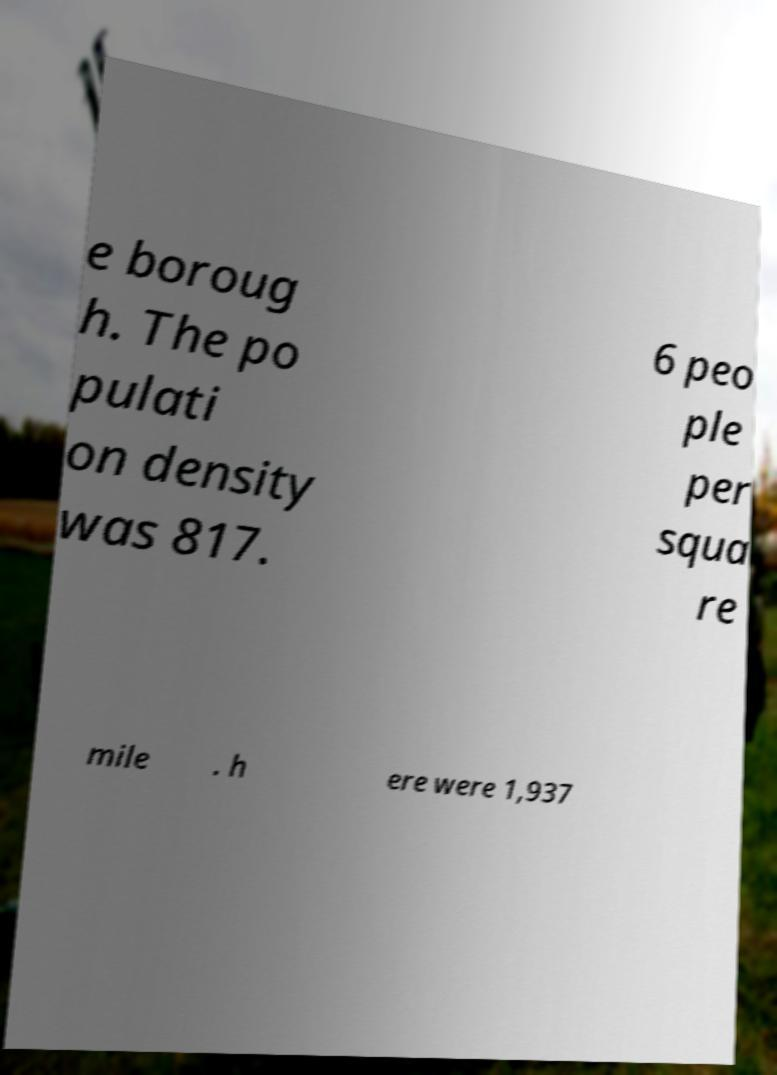There's text embedded in this image that I need extracted. Can you transcribe it verbatim? e boroug h. The po pulati on density was 817. 6 peo ple per squa re mile . h ere were 1,937 